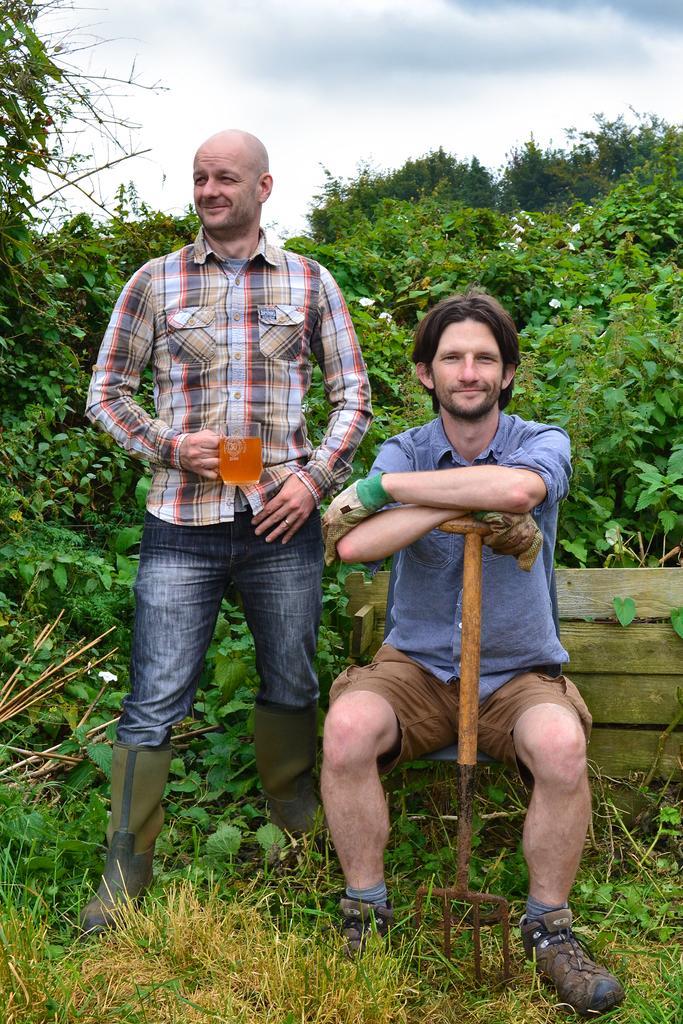Describe this image in one or two sentences. In the foreground of the picture there are men, bench, grass and plants. In the background we can see trees and sky. 